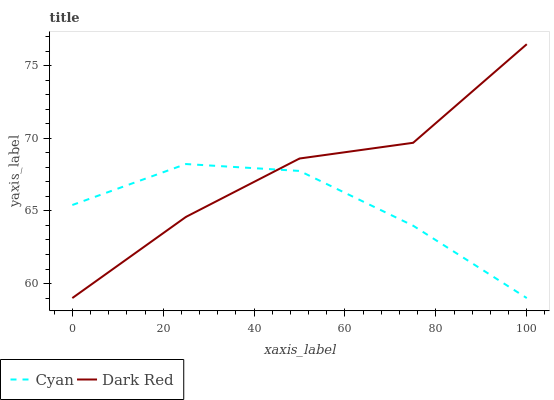Does Cyan have the minimum area under the curve?
Answer yes or no. Yes. Does Dark Red have the maximum area under the curve?
Answer yes or no. Yes. Does Dark Red have the minimum area under the curve?
Answer yes or no. No. Is Cyan the smoothest?
Answer yes or no. Yes. Is Dark Red the roughest?
Answer yes or no. Yes. Is Dark Red the smoothest?
Answer yes or no. No. Does Dark Red have the highest value?
Answer yes or no. Yes. Does Cyan intersect Dark Red?
Answer yes or no. Yes. Is Cyan less than Dark Red?
Answer yes or no. No. Is Cyan greater than Dark Red?
Answer yes or no. No. 